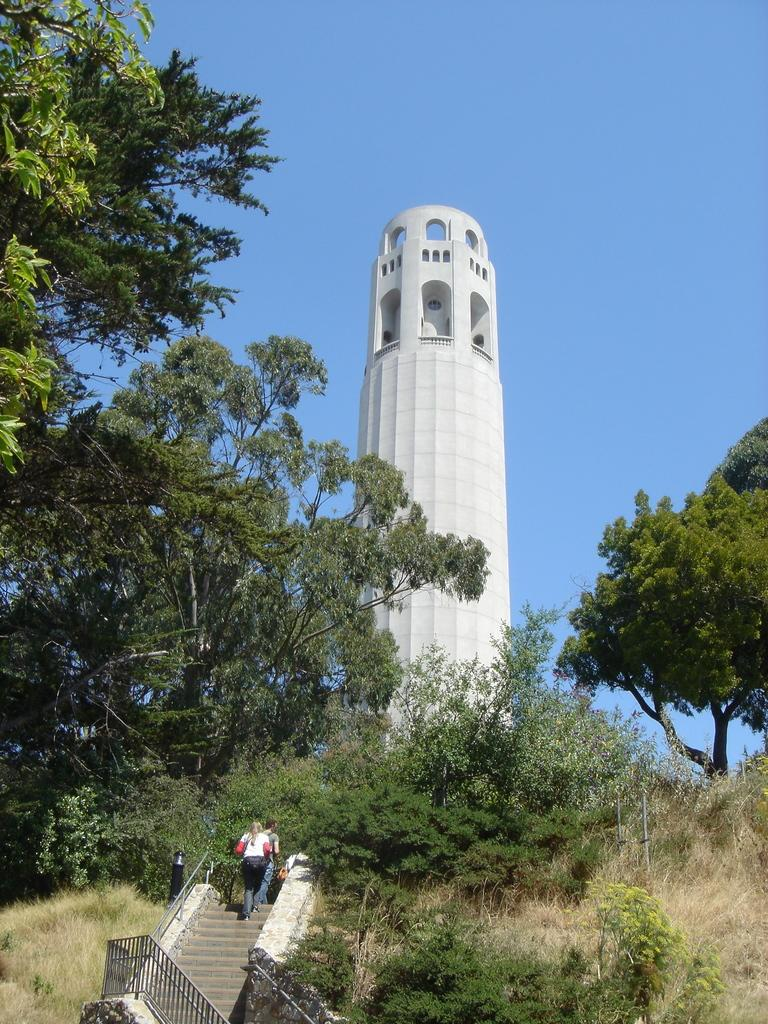What type of structure can be seen in the image? There is a railing and stairs in the image. Are there any people in the image? Yes, there are people standing near the stairs in the image. What is the surrounding environment like? The image shows trees on both sides of the stairs. What can be seen in the background of the image? There is a white-colored tower and the sky visible in the background of the image. What type of wax is being used to clean the railing in the image? There is no wax or cleaning activity depicted in the image; it only shows a railing, stairs, people, trees, a tower, and the sky. 